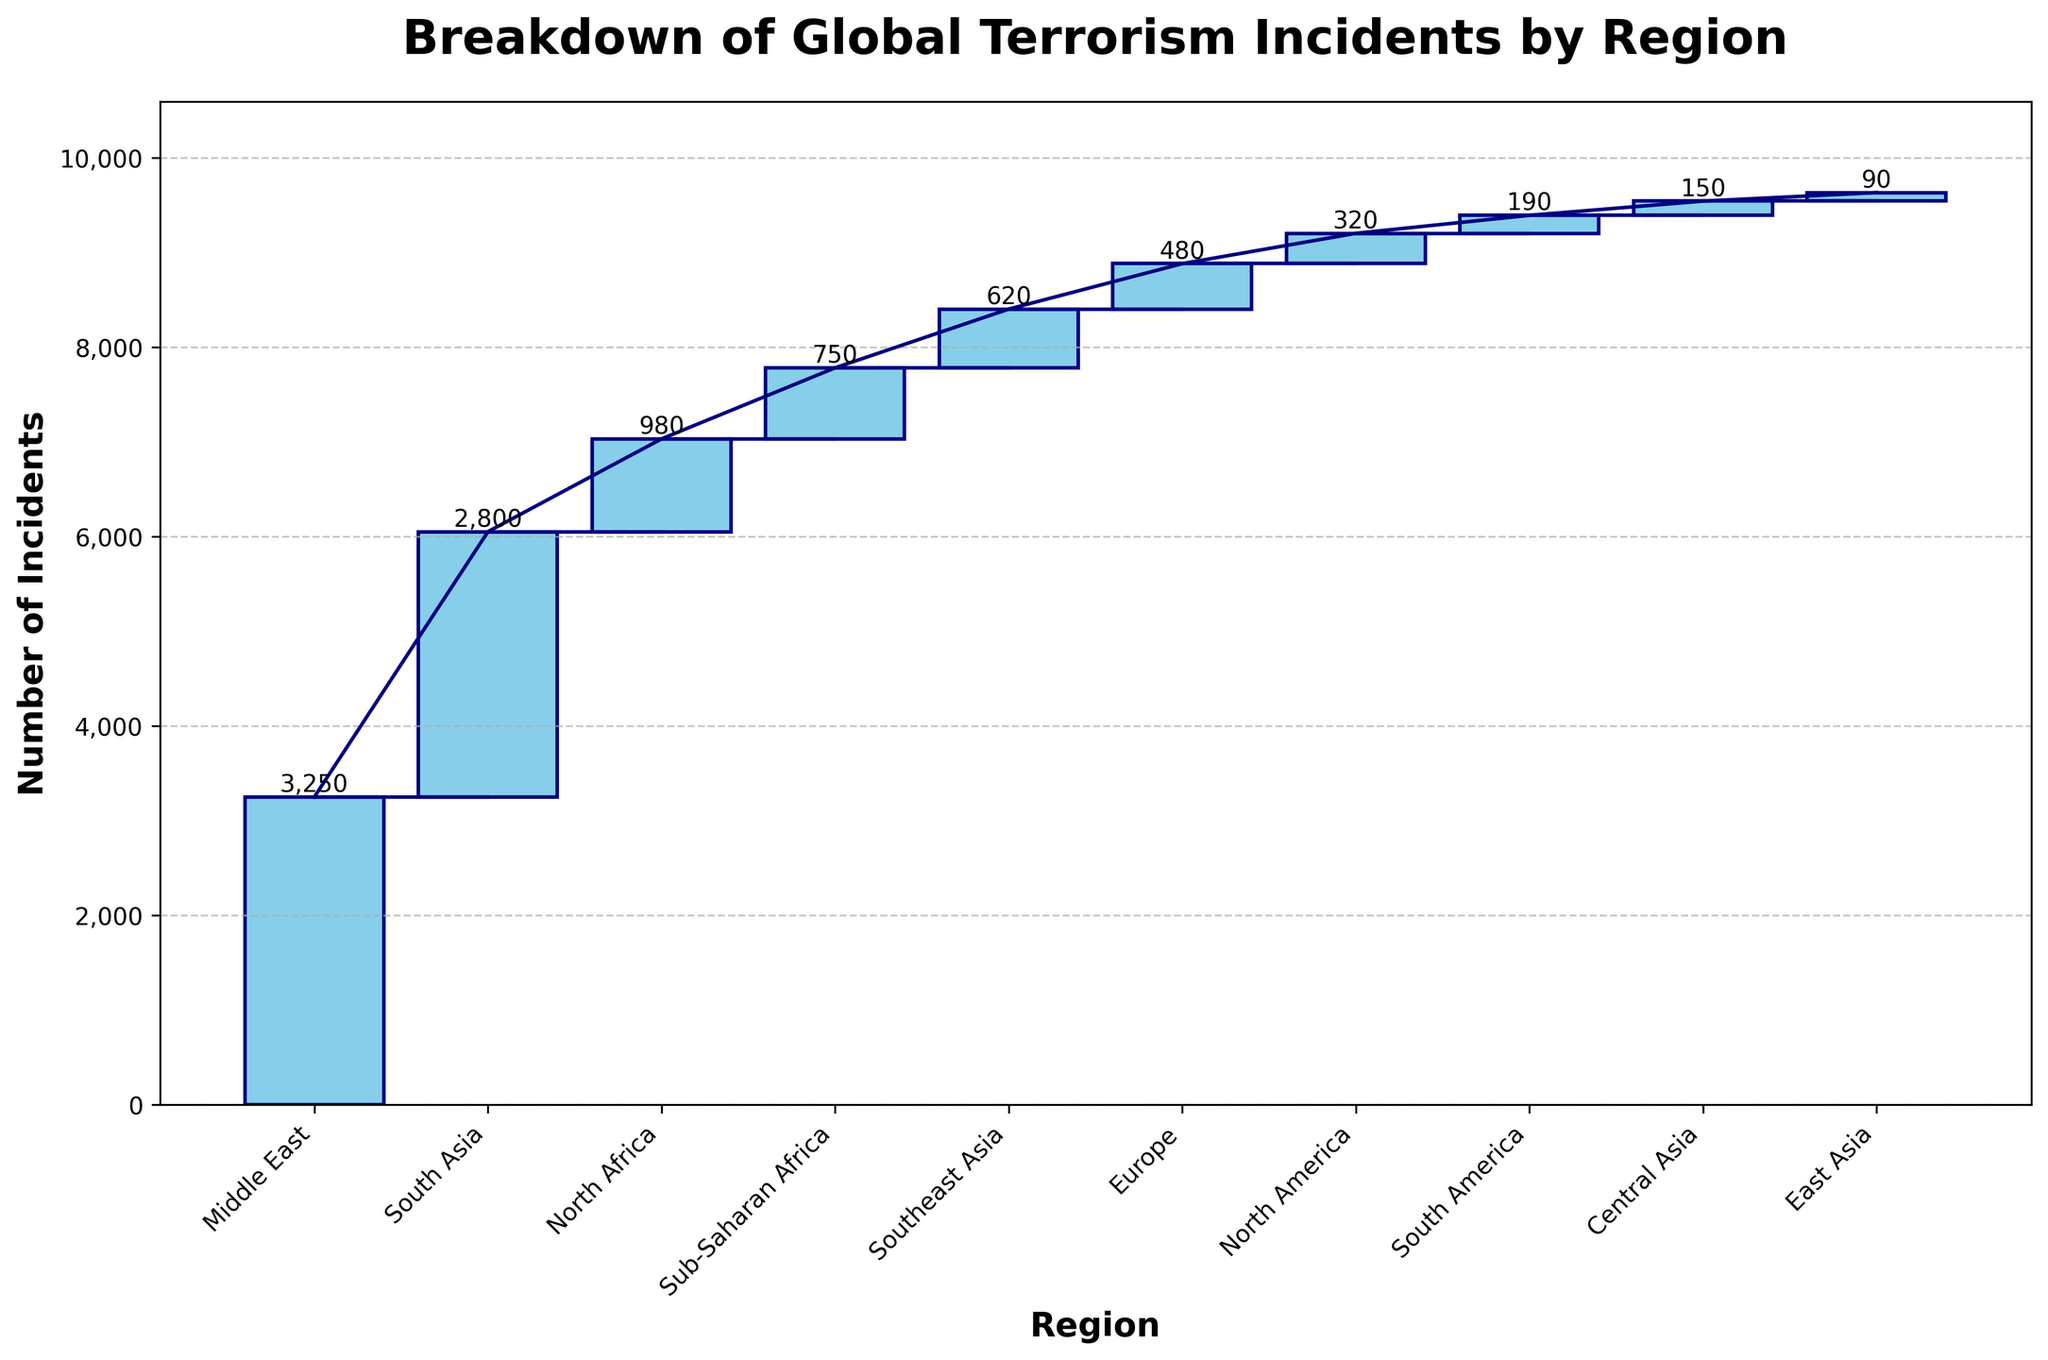What's the title of the chart? The title of the chart is displayed at the top of the figure. It provides a concise summary of the chart's content.
Answer: Breakdown of Global Terrorism Incidents by Region Which region has the highest number of bombing incidents? Look for the region which has the highest bar length for the bombing attack type in the chart. The label 'Middle East' will be found on the x-axis for the highest bar in the ‘Bombing’ category.
Answer: Middle East What is the total number of terrorism incidents in North America? Look for the bar corresponding to North America in the chart and read the label beside it to find the total number.
Answer: 320 Sum the total number of incidents for Sub-Saharan Africa and Southeast Asia. Identify the individual values for Sub-Saharan Africa (750) and Southeast Asia (620). Add them together.
Answer: 1370 What is the cumulative number of incidents up to the North Africa region? Start at the beginning of the chart and sum each bar up to and including North Africa: 3250 (Middle East) + 2800 (South Asia) + 980 (North Africa).
Answer: 7030 Which region has the lowest number of terrorism incidents? Identify the shortest bar on the chart and match it with the corresponding x-axis label.
Answer: East Asia Compare the number of incidents between Sub-Saharan Africa and North Africa. Which region has more incidents? Identify the values for Sub-Saharan Africa (750) and North Africa (980). North Africa has a larger number.
Answer: North Africa What is the cumulative number of incidents after adding those from Southeast Asia? Sum all the values up to and including Southeast Asia starting from the beginning: 3250 (Middle East) + 2800 (South Asia) + 980 (North Africa) + 750 (Sub-Saharan Africa) + 620 (Southeast Asia).
Answer: 8400 How many regions have more than 500 incidents? Count the regions that have bars higher than the 500 incident mark: Middle East, South Asia, North Africa, Sub-Saharan Africa, and Southeast Asia.
Answer: 5 How does the number of incidents in Europe compare to those in North America? Compare the values for Europe (480) and North America (320). Europe has more than North America.
Answer: Europe 